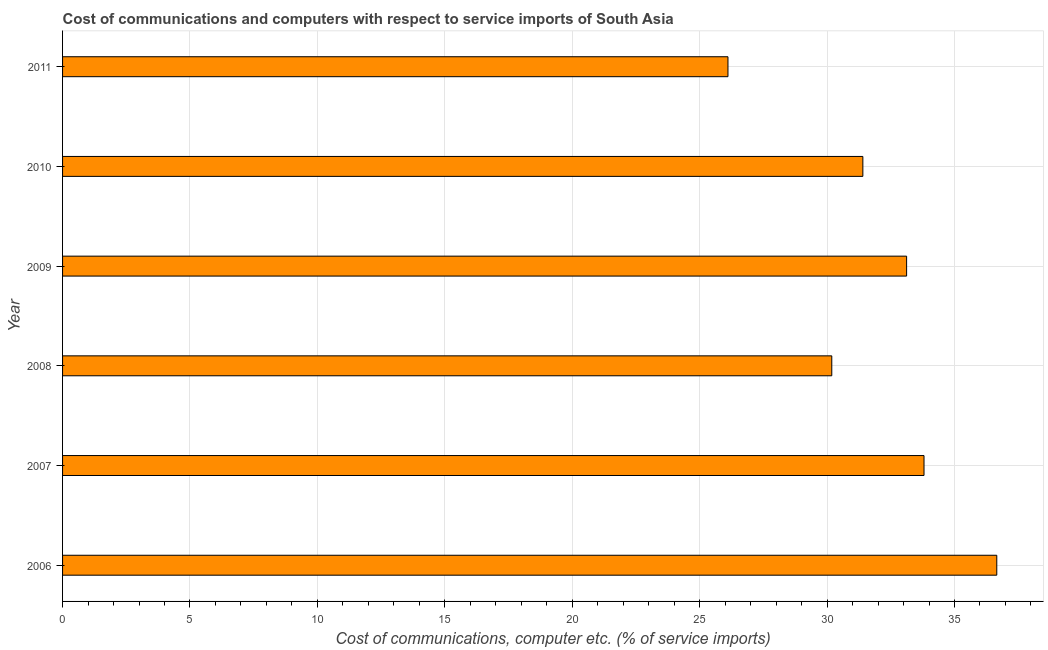What is the title of the graph?
Your answer should be very brief. Cost of communications and computers with respect to service imports of South Asia. What is the label or title of the X-axis?
Your response must be concise. Cost of communications, computer etc. (% of service imports). What is the label or title of the Y-axis?
Provide a succinct answer. Year. What is the cost of communications and computer in 2006?
Provide a short and direct response. 36.66. Across all years, what is the maximum cost of communications and computer?
Offer a very short reply. 36.66. Across all years, what is the minimum cost of communications and computer?
Provide a succinct answer. 26.11. In which year was the cost of communications and computer maximum?
Provide a succinct answer. 2006. What is the sum of the cost of communications and computer?
Offer a terse response. 191.29. What is the difference between the cost of communications and computer in 2009 and 2010?
Offer a terse response. 1.72. What is the average cost of communications and computer per year?
Ensure brevity in your answer.  31.88. What is the median cost of communications and computer?
Your answer should be compact. 32.26. In how many years, is the cost of communications and computer greater than 12 %?
Offer a very short reply. 6. What is the ratio of the cost of communications and computer in 2007 to that in 2008?
Ensure brevity in your answer.  1.12. Is the cost of communications and computer in 2006 less than that in 2011?
Give a very brief answer. No. Is the difference between the cost of communications and computer in 2009 and 2011 greater than the difference between any two years?
Offer a terse response. No. What is the difference between the highest and the second highest cost of communications and computer?
Offer a terse response. 2.85. Is the sum of the cost of communications and computer in 2008 and 2009 greater than the maximum cost of communications and computer across all years?
Provide a succinct answer. Yes. What is the difference between the highest and the lowest cost of communications and computer?
Your response must be concise. 10.55. In how many years, is the cost of communications and computer greater than the average cost of communications and computer taken over all years?
Offer a very short reply. 3. How many bars are there?
Provide a short and direct response. 6. Are the values on the major ticks of X-axis written in scientific E-notation?
Provide a short and direct response. No. What is the Cost of communications, computer etc. (% of service imports) in 2006?
Your response must be concise. 36.66. What is the Cost of communications, computer etc. (% of service imports) in 2007?
Your response must be concise. 33.8. What is the Cost of communications, computer etc. (% of service imports) of 2008?
Keep it short and to the point. 30.18. What is the Cost of communications, computer etc. (% of service imports) of 2009?
Your response must be concise. 33.12. What is the Cost of communications, computer etc. (% of service imports) of 2010?
Provide a short and direct response. 31.4. What is the Cost of communications, computer etc. (% of service imports) in 2011?
Your answer should be compact. 26.11. What is the difference between the Cost of communications, computer etc. (% of service imports) in 2006 and 2007?
Your answer should be very brief. 2.86. What is the difference between the Cost of communications, computer etc. (% of service imports) in 2006 and 2008?
Keep it short and to the point. 6.47. What is the difference between the Cost of communications, computer etc. (% of service imports) in 2006 and 2009?
Provide a succinct answer. 3.54. What is the difference between the Cost of communications, computer etc. (% of service imports) in 2006 and 2010?
Your answer should be compact. 5.25. What is the difference between the Cost of communications, computer etc. (% of service imports) in 2006 and 2011?
Provide a short and direct response. 10.55. What is the difference between the Cost of communications, computer etc. (% of service imports) in 2007 and 2008?
Your answer should be very brief. 3.62. What is the difference between the Cost of communications, computer etc. (% of service imports) in 2007 and 2009?
Provide a succinct answer. 0.68. What is the difference between the Cost of communications, computer etc. (% of service imports) in 2007 and 2010?
Offer a terse response. 2.4. What is the difference between the Cost of communications, computer etc. (% of service imports) in 2007 and 2011?
Keep it short and to the point. 7.69. What is the difference between the Cost of communications, computer etc. (% of service imports) in 2008 and 2009?
Offer a very short reply. -2.94. What is the difference between the Cost of communications, computer etc. (% of service imports) in 2008 and 2010?
Offer a terse response. -1.22. What is the difference between the Cost of communications, computer etc. (% of service imports) in 2008 and 2011?
Your answer should be compact. 4.07. What is the difference between the Cost of communications, computer etc. (% of service imports) in 2009 and 2010?
Keep it short and to the point. 1.72. What is the difference between the Cost of communications, computer etc. (% of service imports) in 2009 and 2011?
Make the answer very short. 7.01. What is the difference between the Cost of communications, computer etc. (% of service imports) in 2010 and 2011?
Your answer should be very brief. 5.29. What is the ratio of the Cost of communications, computer etc. (% of service imports) in 2006 to that in 2007?
Keep it short and to the point. 1.08. What is the ratio of the Cost of communications, computer etc. (% of service imports) in 2006 to that in 2008?
Keep it short and to the point. 1.22. What is the ratio of the Cost of communications, computer etc. (% of service imports) in 2006 to that in 2009?
Give a very brief answer. 1.11. What is the ratio of the Cost of communications, computer etc. (% of service imports) in 2006 to that in 2010?
Offer a very short reply. 1.17. What is the ratio of the Cost of communications, computer etc. (% of service imports) in 2006 to that in 2011?
Offer a terse response. 1.4. What is the ratio of the Cost of communications, computer etc. (% of service imports) in 2007 to that in 2008?
Provide a succinct answer. 1.12. What is the ratio of the Cost of communications, computer etc. (% of service imports) in 2007 to that in 2009?
Your answer should be compact. 1.02. What is the ratio of the Cost of communications, computer etc. (% of service imports) in 2007 to that in 2010?
Offer a terse response. 1.08. What is the ratio of the Cost of communications, computer etc. (% of service imports) in 2007 to that in 2011?
Your response must be concise. 1.29. What is the ratio of the Cost of communications, computer etc. (% of service imports) in 2008 to that in 2009?
Your response must be concise. 0.91. What is the ratio of the Cost of communications, computer etc. (% of service imports) in 2008 to that in 2010?
Provide a succinct answer. 0.96. What is the ratio of the Cost of communications, computer etc. (% of service imports) in 2008 to that in 2011?
Offer a terse response. 1.16. What is the ratio of the Cost of communications, computer etc. (% of service imports) in 2009 to that in 2010?
Your answer should be very brief. 1.05. What is the ratio of the Cost of communications, computer etc. (% of service imports) in 2009 to that in 2011?
Make the answer very short. 1.27. What is the ratio of the Cost of communications, computer etc. (% of service imports) in 2010 to that in 2011?
Your answer should be very brief. 1.2. 